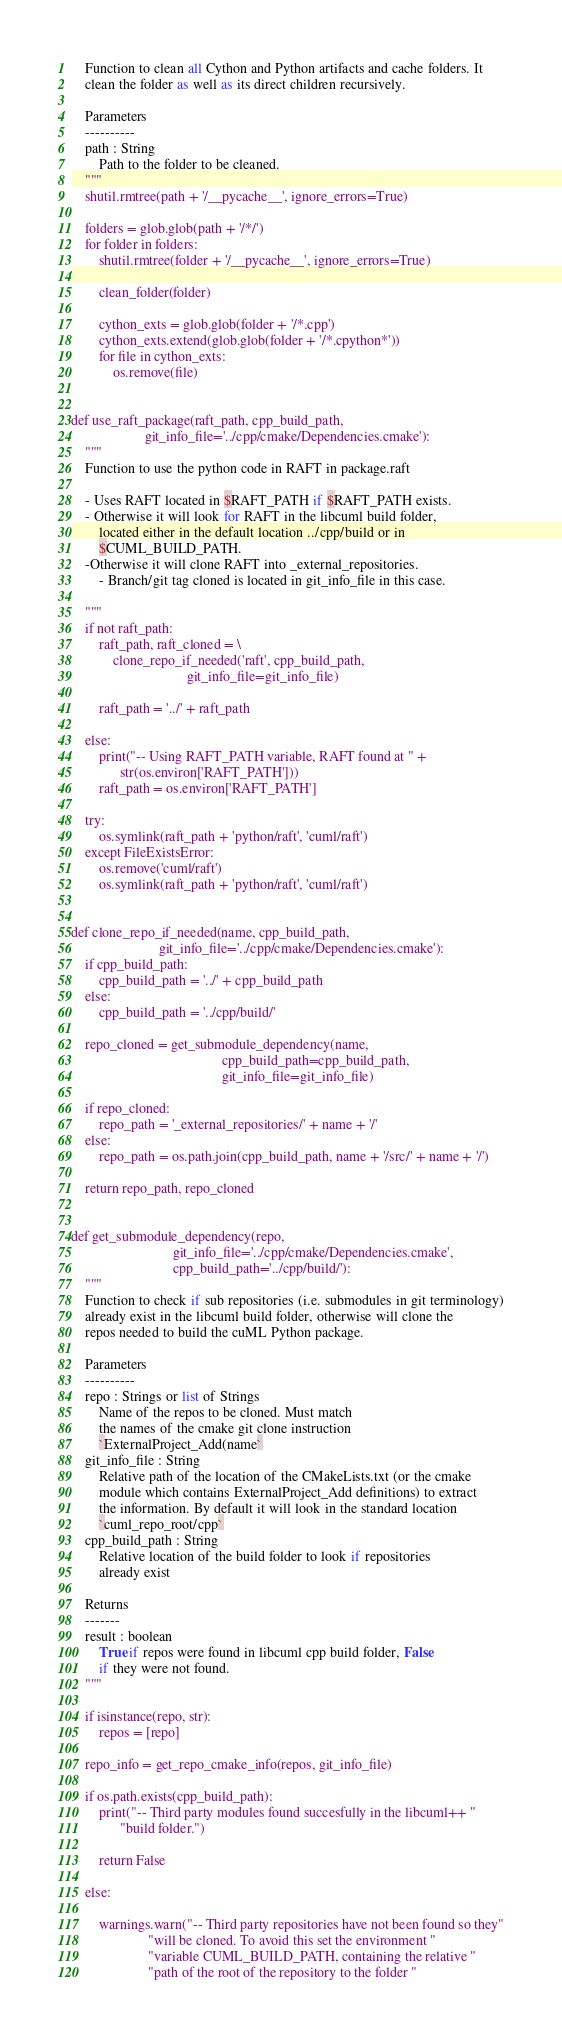<code> <loc_0><loc_0><loc_500><loc_500><_Python_>    Function to clean all Cython and Python artifacts and cache folders. It
    clean the folder as well as its direct children recursively.

    Parameters
    ----------
    path : String
        Path to the folder to be cleaned.
    """
    shutil.rmtree(path + '/__pycache__', ignore_errors=True)

    folders = glob.glob(path + '/*/')
    for folder in folders:
        shutil.rmtree(folder + '/__pycache__', ignore_errors=True)

        clean_folder(folder)

        cython_exts = glob.glob(folder + '/*.cpp')
        cython_exts.extend(glob.glob(folder + '/*.cpython*'))
        for file in cython_exts:
            os.remove(file)


def use_raft_package(raft_path, cpp_build_path,
                     git_info_file='../cpp/cmake/Dependencies.cmake'):
    """
    Function to use the python code in RAFT in package.raft

    - Uses RAFT located in $RAFT_PATH if $RAFT_PATH exists.
    - Otherwise it will look for RAFT in the libcuml build folder,
        located either in the default location ../cpp/build or in
        $CUML_BUILD_PATH.
    -Otherwise it will clone RAFT into _external_repositories.
        - Branch/git tag cloned is located in git_info_file in this case.

    """
    if not raft_path:
        raft_path, raft_cloned = \
            clone_repo_if_needed('raft', cpp_build_path,
                                 git_info_file=git_info_file)

        raft_path = '../' + raft_path

    else:
        print("-- Using RAFT_PATH variable, RAFT found at " +
              str(os.environ['RAFT_PATH']))
        raft_path = os.environ['RAFT_PATH']

    try:
        os.symlink(raft_path + 'python/raft', 'cuml/raft')
    except FileExistsError:
        os.remove('cuml/raft')
        os.symlink(raft_path + 'python/raft', 'cuml/raft')


def clone_repo_if_needed(name, cpp_build_path,
                         git_info_file='../cpp/cmake/Dependencies.cmake'):
    if cpp_build_path:
        cpp_build_path = '../' + cpp_build_path
    else:
        cpp_build_path = '../cpp/build/'

    repo_cloned = get_submodule_dependency(name,
                                           cpp_build_path=cpp_build_path,
                                           git_info_file=git_info_file)

    if repo_cloned:
        repo_path = '_external_repositories/' + name + '/'
    else:
        repo_path = os.path.join(cpp_build_path, name + '/src/' + name + '/')

    return repo_path, repo_cloned


def get_submodule_dependency(repo,
                             git_info_file='../cpp/cmake/Dependencies.cmake',
                             cpp_build_path='../cpp/build/'):
    """
    Function to check if sub repositories (i.e. submodules in git terminology)
    already exist in the libcuml build folder, otherwise will clone the
    repos needed to build the cuML Python package.

    Parameters
    ----------
    repo : Strings or list of Strings
        Name of the repos to be cloned. Must match
        the names of the cmake git clone instruction
        `ExternalProject_Add(name`
    git_info_file : String
        Relative path of the location of the CMakeLists.txt (or the cmake
        module which contains ExternalProject_Add definitions) to extract
        the information. By default it will look in the standard location
        `cuml_repo_root/cpp`
    cpp_build_path : String
        Relative location of the build folder to look if repositories
        already exist

    Returns
    -------
    result : boolean
        True if repos were found in libcuml cpp build folder, False
        if they were not found.
    """

    if isinstance(repo, str):
        repos = [repo]

    repo_info = get_repo_cmake_info(repos, git_info_file)

    if os.path.exists(cpp_build_path):
        print("-- Third party modules found succesfully in the libcuml++ "
              "build folder.")

        return False

    else:

        warnings.warn("-- Third party repositories have not been found so they"
                      "will be cloned. To avoid this set the environment "
                      "variable CUML_BUILD_PATH, containing the relative "
                      "path of the root of the repository to the folder "</code> 